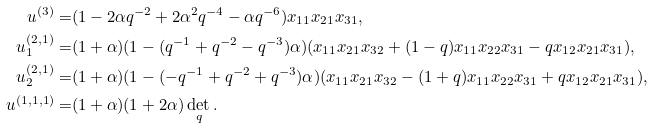Convert formula to latex. <formula><loc_0><loc_0><loc_500><loc_500>u ^ { ( 3 ) } = & ( 1 - 2 \alpha q ^ { - 2 } + 2 \alpha ^ { 2 } q ^ { - 4 } - \alpha q ^ { - 6 } ) x _ { 1 1 } x _ { 2 1 } x _ { 3 1 } , \\ u _ { 1 } ^ { ( 2 , 1 ) } = & ( 1 + \alpha ) ( 1 - ( q ^ { - 1 } + q ^ { - 2 } - q ^ { - 3 } ) \alpha ) ( x _ { 1 1 } x _ { 2 1 } x _ { 3 2 } + ( 1 - q ) x _ { 1 1 } x _ { 2 2 } x _ { 3 1 } - q x _ { 1 2 } x _ { 2 1 } x _ { 3 1 } ) , \\ u _ { 2 } ^ { ( 2 , 1 ) } = & ( 1 + \alpha ) ( 1 - ( - q ^ { - 1 } + q ^ { - 2 } + q ^ { - 3 } ) \alpha ) ( x _ { 1 1 } x _ { 2 1 } x _ { 3 2 } - ( 1 + q ) x _ { 1 1 } x _ { 2 2 } x _ { 3 1 } + q x _ { 1 2 } x _ { 2 1 } x _ { 3 1 } ) , \\ u ^ { ( 1 , 1 , 1 ) } = & ( 1 + \alpha ) ( 1 + 2 \alpha ) \det _ { q } .</formula> 